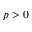Convert formula to latex. <formula><loc_0><loc_0><loc_500><loc_500>p > 0</formula> 